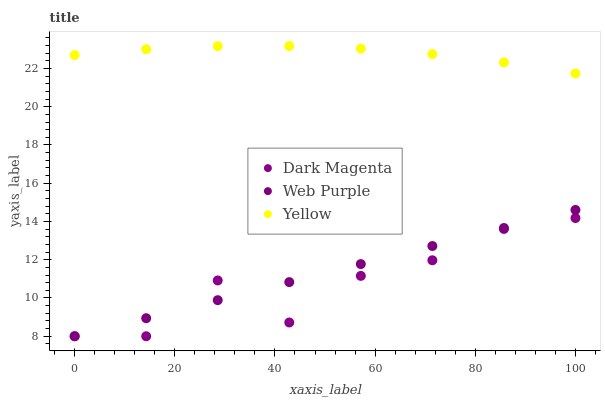Does Dark Magenta have the minimum area under the curve?
Answer yes or no. Yes. Does Yellow have the maximum area under the curve?
Answer yes or no. Yes. Does Yellow have the minimum area under the curve?
Answer yes or no. No. Does Dark Magenta have the maximum area under the curve?
Answer yes or no. No. Is Web Purple the smoothest?
Answer yes or no. Yes. Is Dark Magenta the roughest?
Answer yes or no. Yes. Is Yellow the smoothest?
Answer yes or no. No. Is Yellow the roughest?
Answer yes or no. No. Does Web Purple have the lowest value?
Answer yes or no. Yes. Does Yellow have the lowest value?
Answer yes or no. No. Does Yellow have the highest value?
Answer yes or no. Yes. Does Dark Magenta have the highest value?
Answer yes or no. No. Is Web Purple less than Yellow?
Answer yes or no. Yes. Is Yellow greater than Dark Magenta?
Answer yes or no. Yes. Does Dark Magenta intersect Web Purple?
Answer yes or no. Yes. Is Dark Magenta less than Web Purple?
Answer yes or no. No. Is Dark Magenta greater than Web Purple?
Answer yes or no. No. Does Web Purple intersect Yellow?
Answer yes or no. No. 